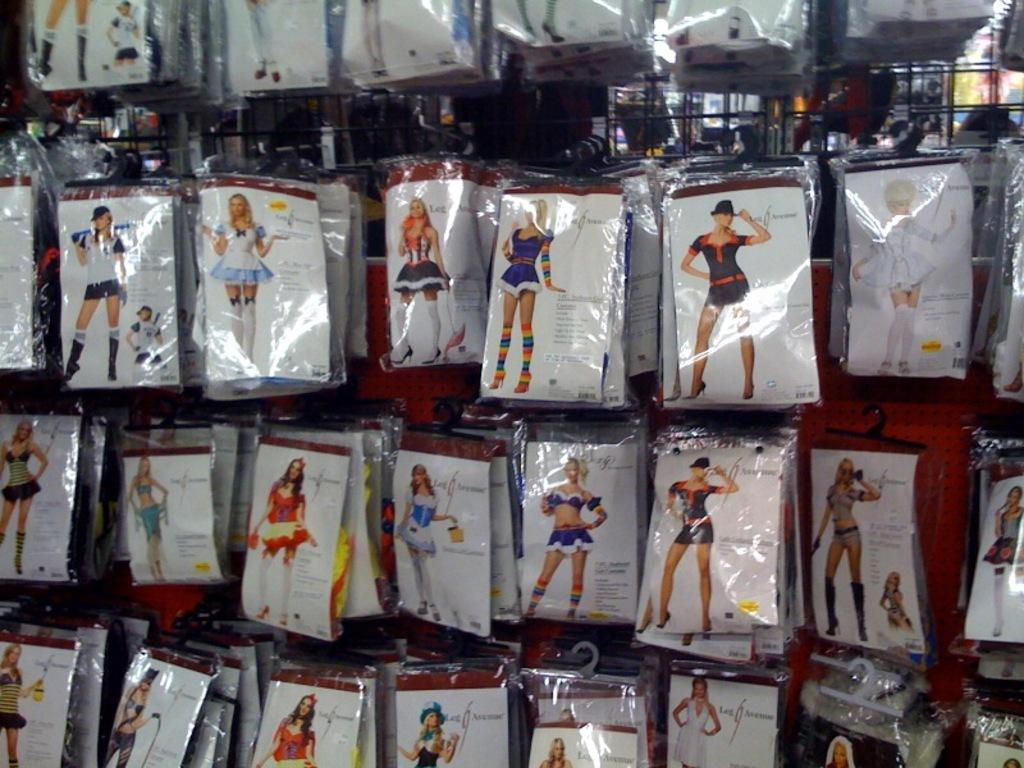What is depicted on the packets in the image? There are pictures of persons on the packets in the image. Can you see a farmer using a rake in the image? There is no farmer or rake present in the image; the image only shows packets with pictures of persons. 